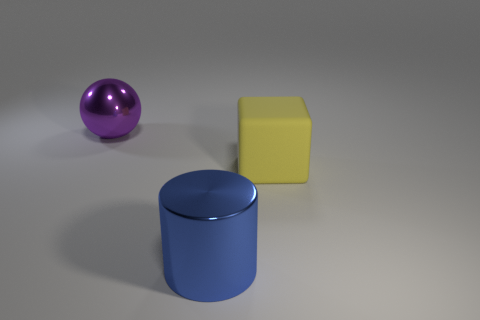Add 1 big purple balls. How many objects exist? 4 Subtract all spheres. How many objects are left? 2 Add 3 big blocks. How many big blocks are left? 4 Add 1 metallic cylinders. How many metallic cylinders exist? 2 Subtract 0 brown blocks. How many objects are left? 3 Subtract all gray matte cylinders. Subtract all large metal spheres. How many objects are left? 2 